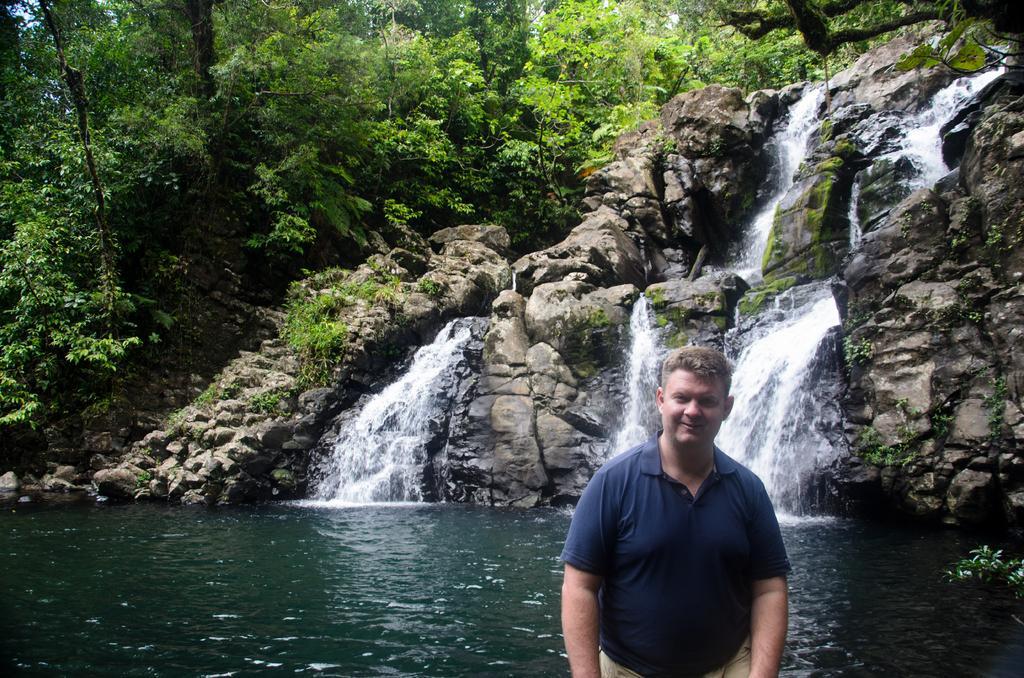In one or two sentences, can you explain what this image depicts? In this image I can see the person standing and the person is wearing blue and cream color dress. Background I can see the water flowing, few trees in green color and the sky is in blue color. 